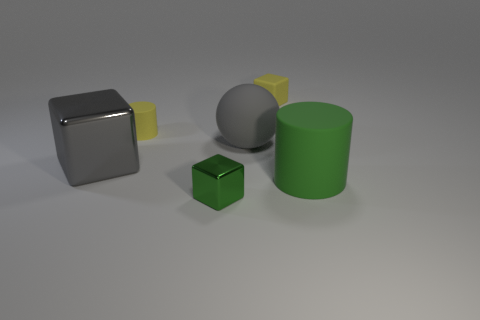Subtract all small rubber cubes. How many cubes are left? 2 Add 3 large blue metal cylinders. How many objects exist? 9 Subtract all green cubes. How many cubes are left? 2 Subtract 3 blocks. How many blocks are left? 0 Add 6 big gray spheres. How many big gray spheres exist? 7 Subtract 0 cyan cylinders. How many objects are left? 6 Subtract all cylinders. How many objects are left? 4 Subtract all red cubes. Subtract all green balls. How many cubes are left? 3 Subtract all blue balls. How many gray blocks are left? 1 Subtract all big rubber objects. Subtract all tiny matte things. How many objects are left? 2 